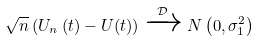Convert formula to latex. <formula><loc_0><loc_0><loc_500><loc_500>\sqrt { n } \left ( U _ { n } \left ( t \right ) - U ( t ) \right ) \xrightarrow { \mathcal { D } } N \left ( 0 , \sigma ^ { 2 } _ { 1 } \right )</formula> 